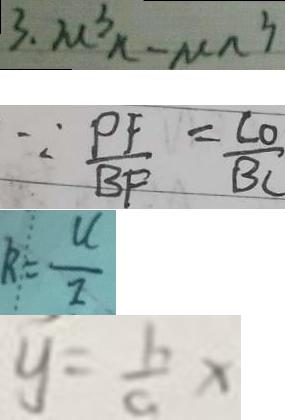Convert formula to latex. <formula><loc_0><loc_0><loc_500><loc_500>3 . \mu ^ { 3 } n - \mu n ^ { 3 } 
 \because \frac { P F } { B F } = \frac { C O } { B C } 
 R = \frac { U } { I } 
 y = \frac { b } { a } x</formula> 